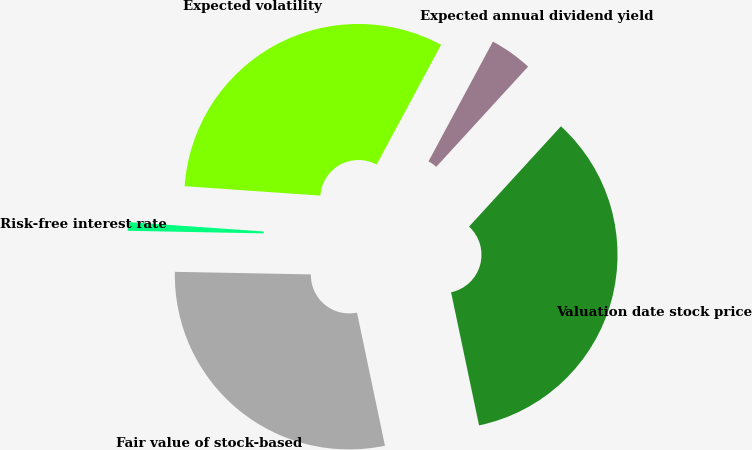<chart> <loc_0><loc_0><loc_500><loc_500><pie_chart><fcel>Valuation date stock price<fcel>Expected annual dividend yield<fcel>Expected volatility<fcel>Risk-free interest rate<fcel>Fair value of stock-based<nl><fcel>34.9%<fcel>3.95%<fcel>31.75%<fcel>0.8%<fcel>28.6%<nl></chart> 